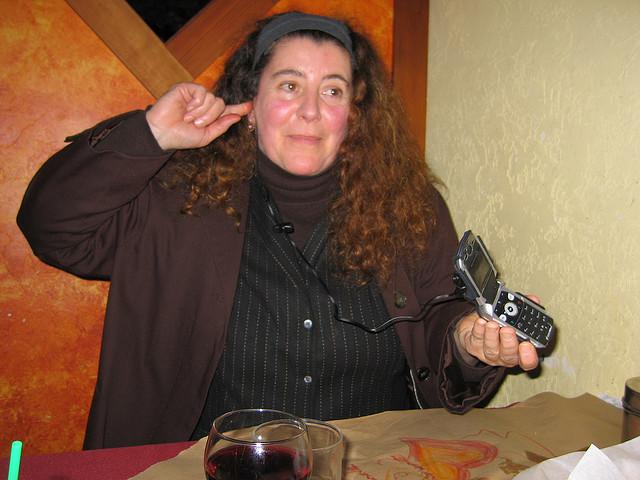Is the lady wearing pinstripes?
Keep it brief. Yes. Who is in the photo?
Be succinct. Woman. Is she holding a flip phone?
Quick response, please. Yes. What color is the lady's jacket?
Write a very short answer. Brown. 